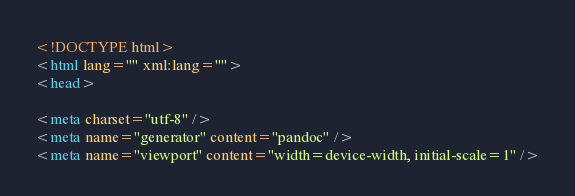<code> <loc_0><loc_0><loc_500><loc_500><_HTML_><!DOCTYPE html>
<html lang="" xml:lang="">
<head>

<meta charset="utf-8" />
<meta name="generator" content="pandoc" />
<meta name="viewport" content="width=device-width, initial-scale=1" /></code> 